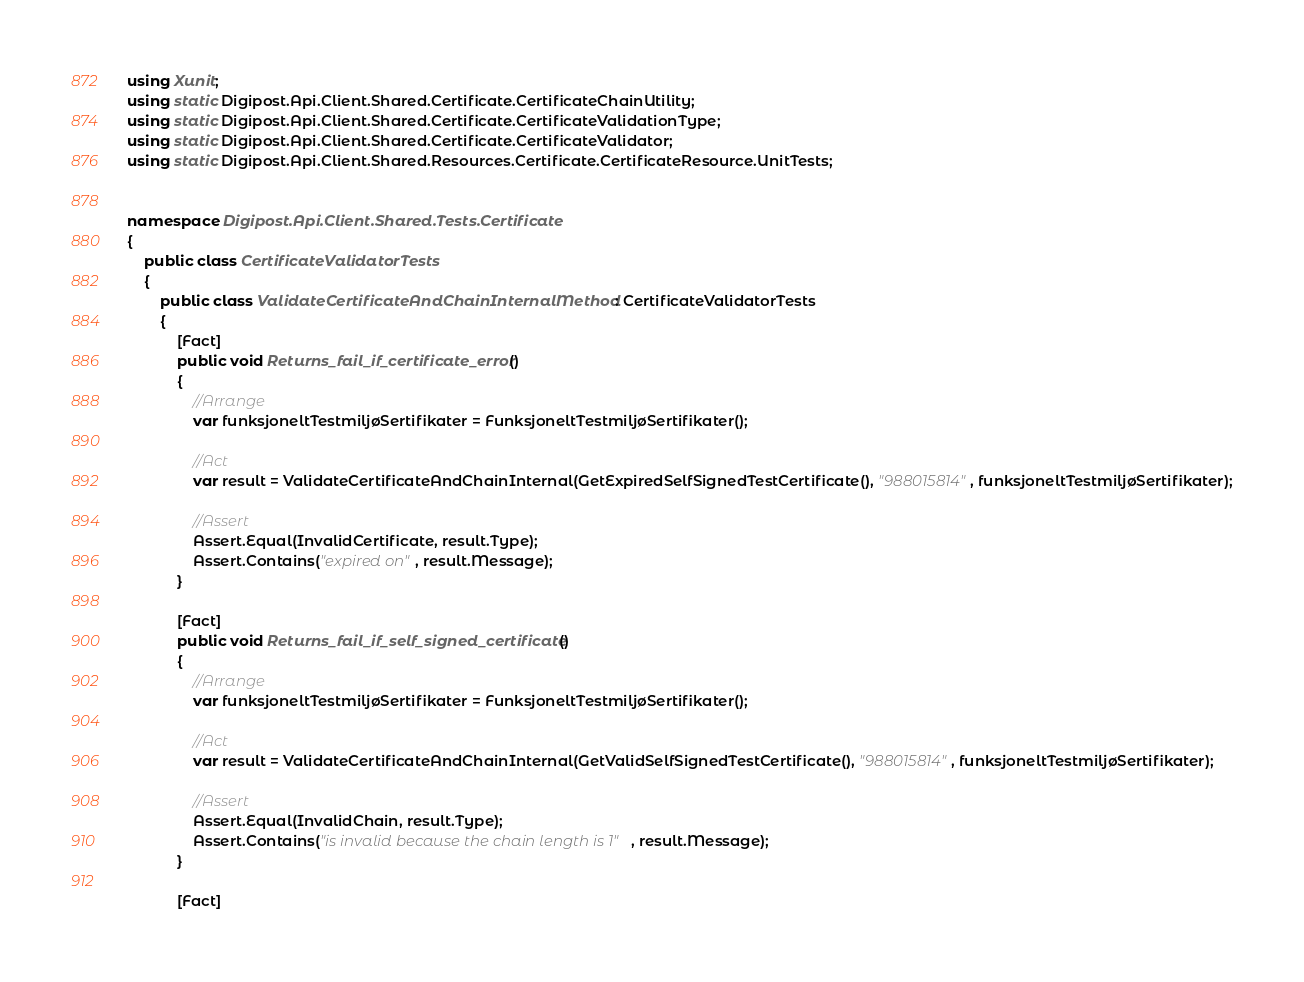Convert code to text. <code><loc_0><loc_0><loc_500><loc_500><_C#_>using Xunit;
using static Digipost.Api.Client.Shared.Certificate.CertificateChainUtility;
using static Digipost.Api.Client.Shared.Certificate.CertificateValidationType;
using static Digipost.Api.Client.Shared.Certificate.CertificateValidator;
using static Digipost.Api.Client.Shared.Resources.Certificate.CertificateResource.UnitTests;


namespace Digipost.Api.Client.Shared.Tests.Certificate
{
    public class CertificateValidatorTests
    {
        public class ValidateCertificateAndChainInternalMethod : CertificateValidatorTests
        {
            [Fact]
            public void Returns_fail_if_certificate_error()
            {
                //Arrange
                var funksjoneltTestmiljøSertifikater = FunksjoneltTestmiljøSertifikater();

                //Act
                var result = ValidateCertificateAndChainInternal(GetExpiredSelfSignedTestCertificate(), "988015814", funksjoneltTestmiljøSertifikater);

                //Assert
                Assert.Equal(InvalidCertificate, result.Type);
                Assert.Contains("expired on", result.Message);
            }

            [Fact]
            public void Returns_fail_if_self_signed_certificate()
            {
                //Arrange
                var funksjoneltTestmiljøSertifikater = FunksjoneltTestmiljøSertifikater();

                //Act
                var result = ValidateCertificateAndChainInternal(GetValidSelfSignedTestCertificate(), "988015814", funksjoneltTestmiljøSertifikater);

                //Assert
                Assert.Equal(InvalidChain, result.Type);
                Assert.Contains("is invalid because the chain length is 1", result.Message);
            }
            
            [Fact]</code> 